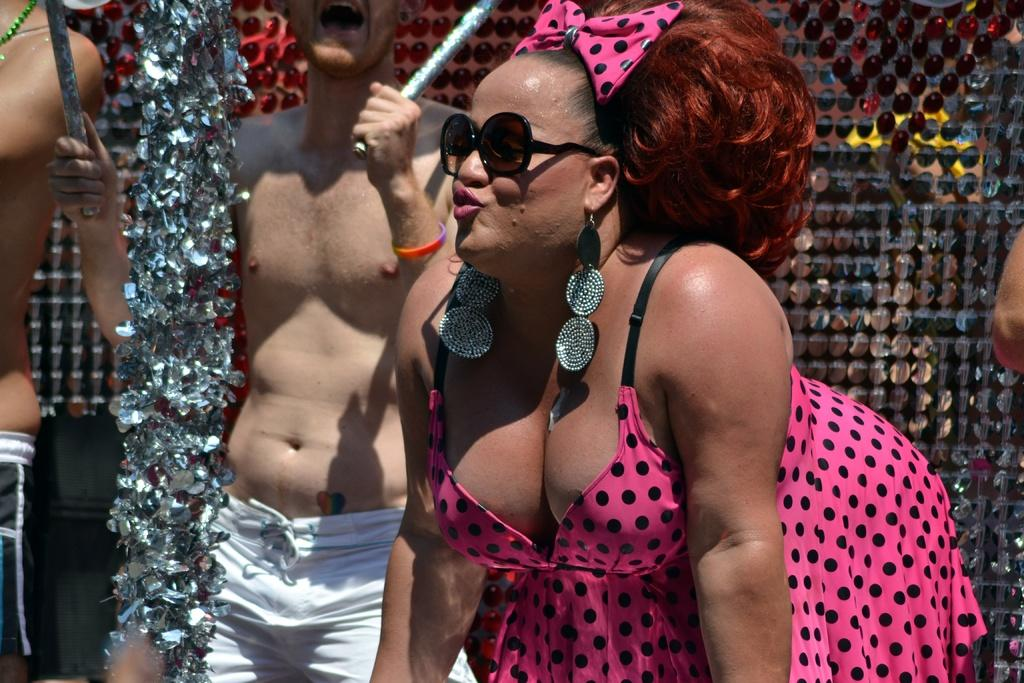How many people are in the image? There are three persons in the image. What are the persons doing in the image? One of the persons is holding sticks. What can be seen in the background of the image? There is a decorative fence visible in the background. Can you describe any body parts visible in the image? A person's hand is visible on the right side of the image. What type of advice is being given in the image? There is no indication in the image that any advice is being given. Can you hear the whistle in the image? There is no whistle present in the image, so it cannot be heard. 